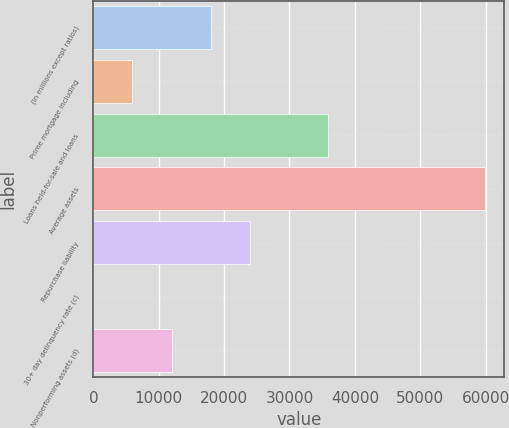Convert chart. <chart><loc_0><loc_0><loc_500><loc_500><bar_chart><fcel>(in millions except ratios)<fcel>Prime mortgage including<fcel>Loans held-for-sale and loans<fcel>Average assets<fcel>Repurchase liability<fcel>30+ day delinquency rate (c)<fcel>Nonperforming assets (d)<nl><fcel>17953.2<fcel>5986.45<fcel>35903.4<fcel>59837<fcel>23936.7<fcel>3.05<fcel>11969.9<nl></chart> 